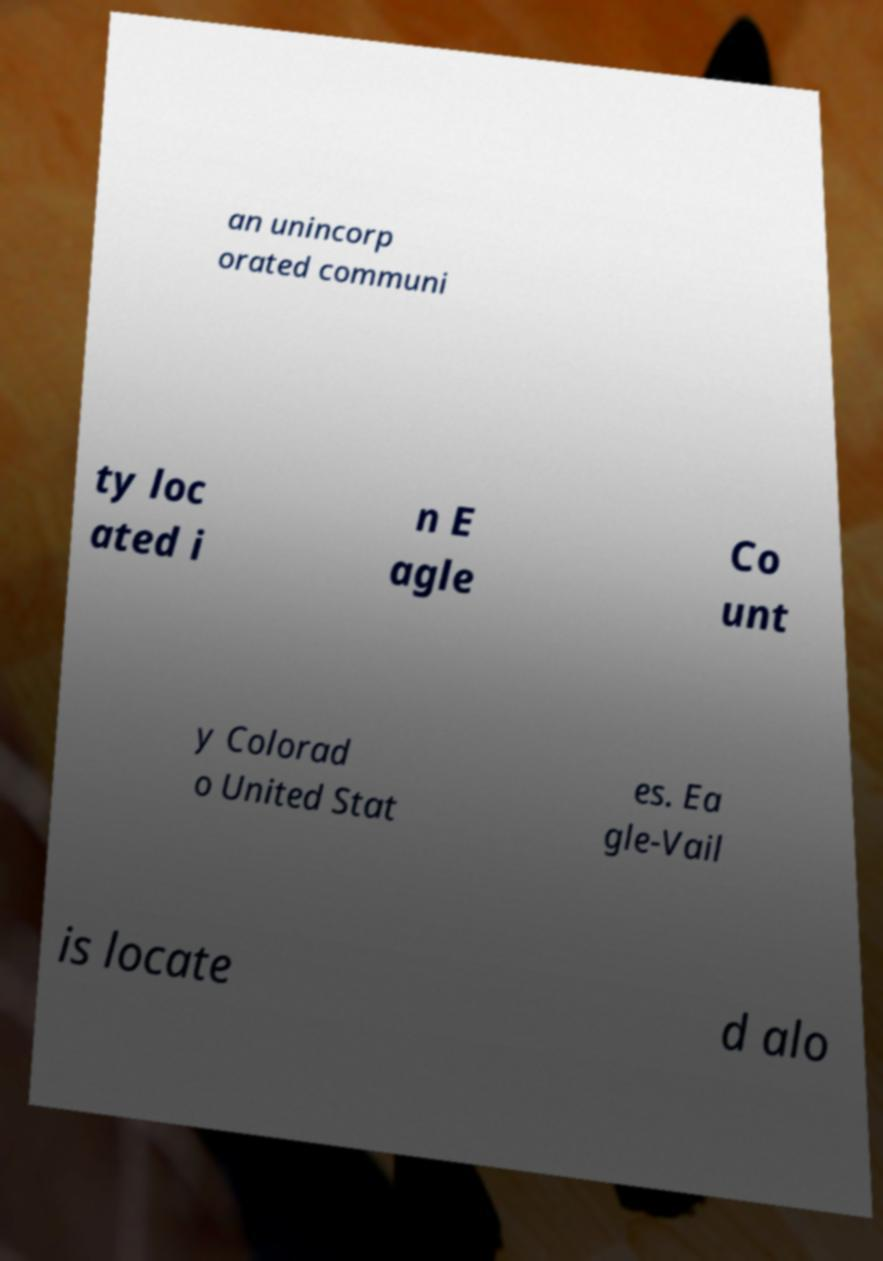Could you assist in decoding the text presented in this image and type it out clearly? an unincorp orated communi ty loc ated i n E agle Co unt y Colorad o United Stat es. Ea gle-Vail is locate d alo 